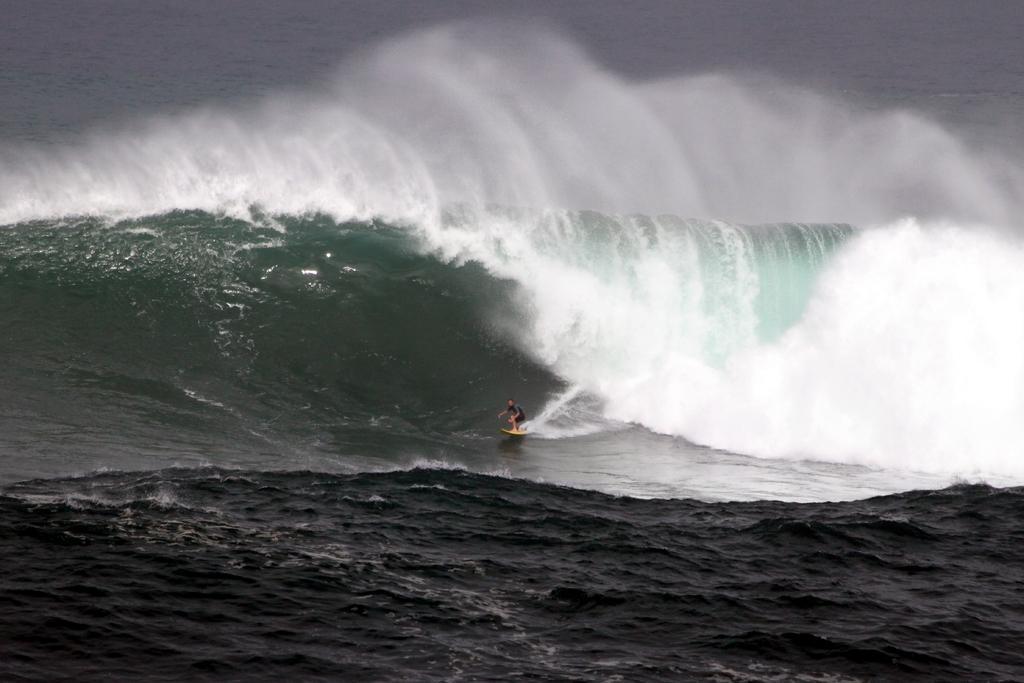Please provide a concise description of this image. In this picture we can see a person on a surfboard. Waves are visible in the water. 